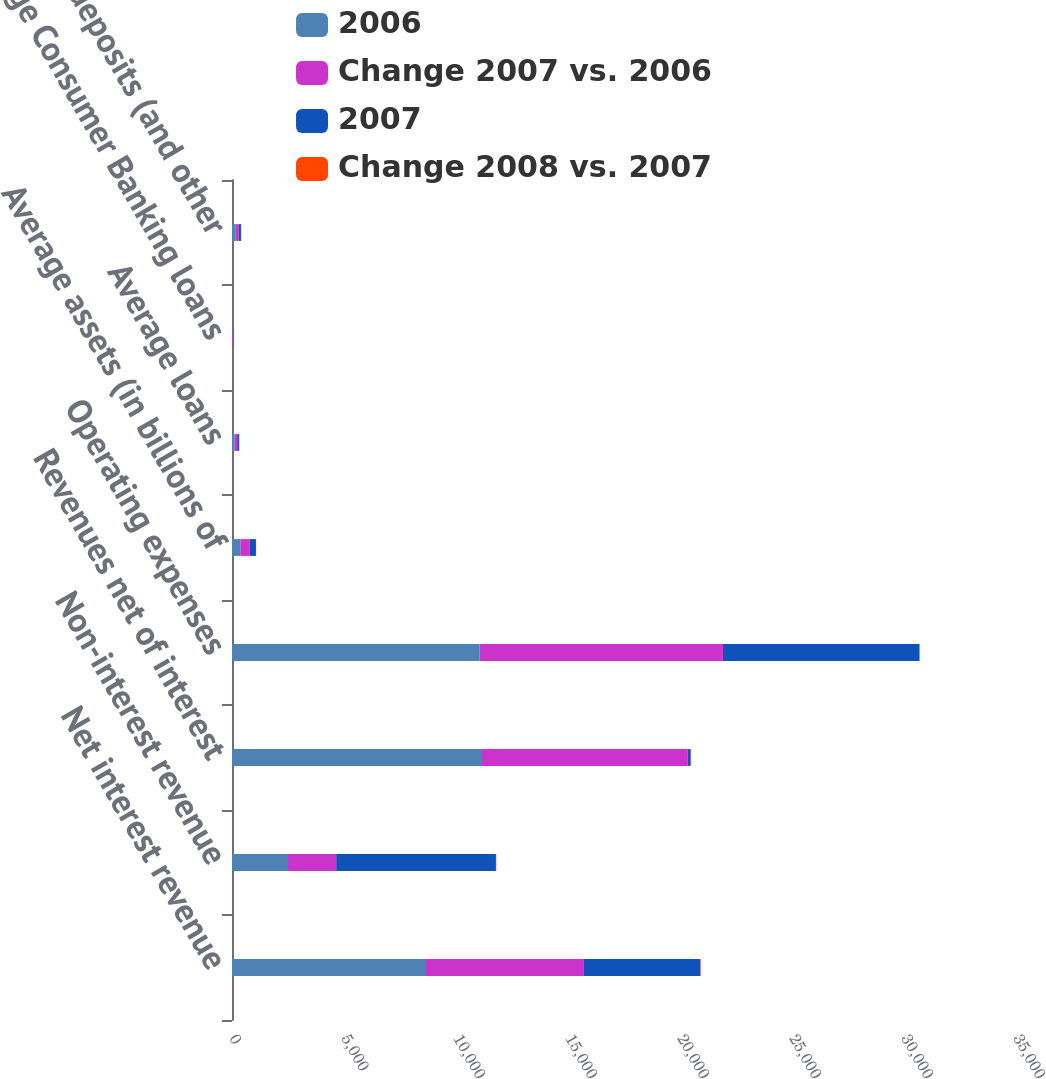Convert chart to OTSL. <chart><loc_0><loc_0><loc_500><loc_500><stacked_bar_chart><ecel><fcel>Net interest revenue<fcel>Non-interest revenue<fcel>Revenues net of interest<fcel>Operating expenses<fcel>Average assets (in billions of<fcel>Average loans<fcel>Average Consumer Banking loans<fcel>Average deposits (and other<nl><fcel>2006<fcel>8618<fcel>2500<fcel>11118<fcel>11051<fcel>373<fcel>115.5<fcel>24.5<fcel>159<nl><fcel>Change 2007 vs. 2006<fcel>7067<fcel>2151<fcel>9218<fcel>10864<fcel>406<fcel>117.5<fcel>22.2<fcel>140.3<nl><fcel>2007<fcel>5222<fcel>7131<fcel>140.3<fcel>8778<fcel>290<fcel>87.2<fcel>16.1<fcel>99.6<nl><fcel>Change 2008 vs. 2007<fcel>22<fcel>16<fcel>21<fcel>2<fcel>8<fcel>2<fcel>10<fcel>13<nl></chart> 